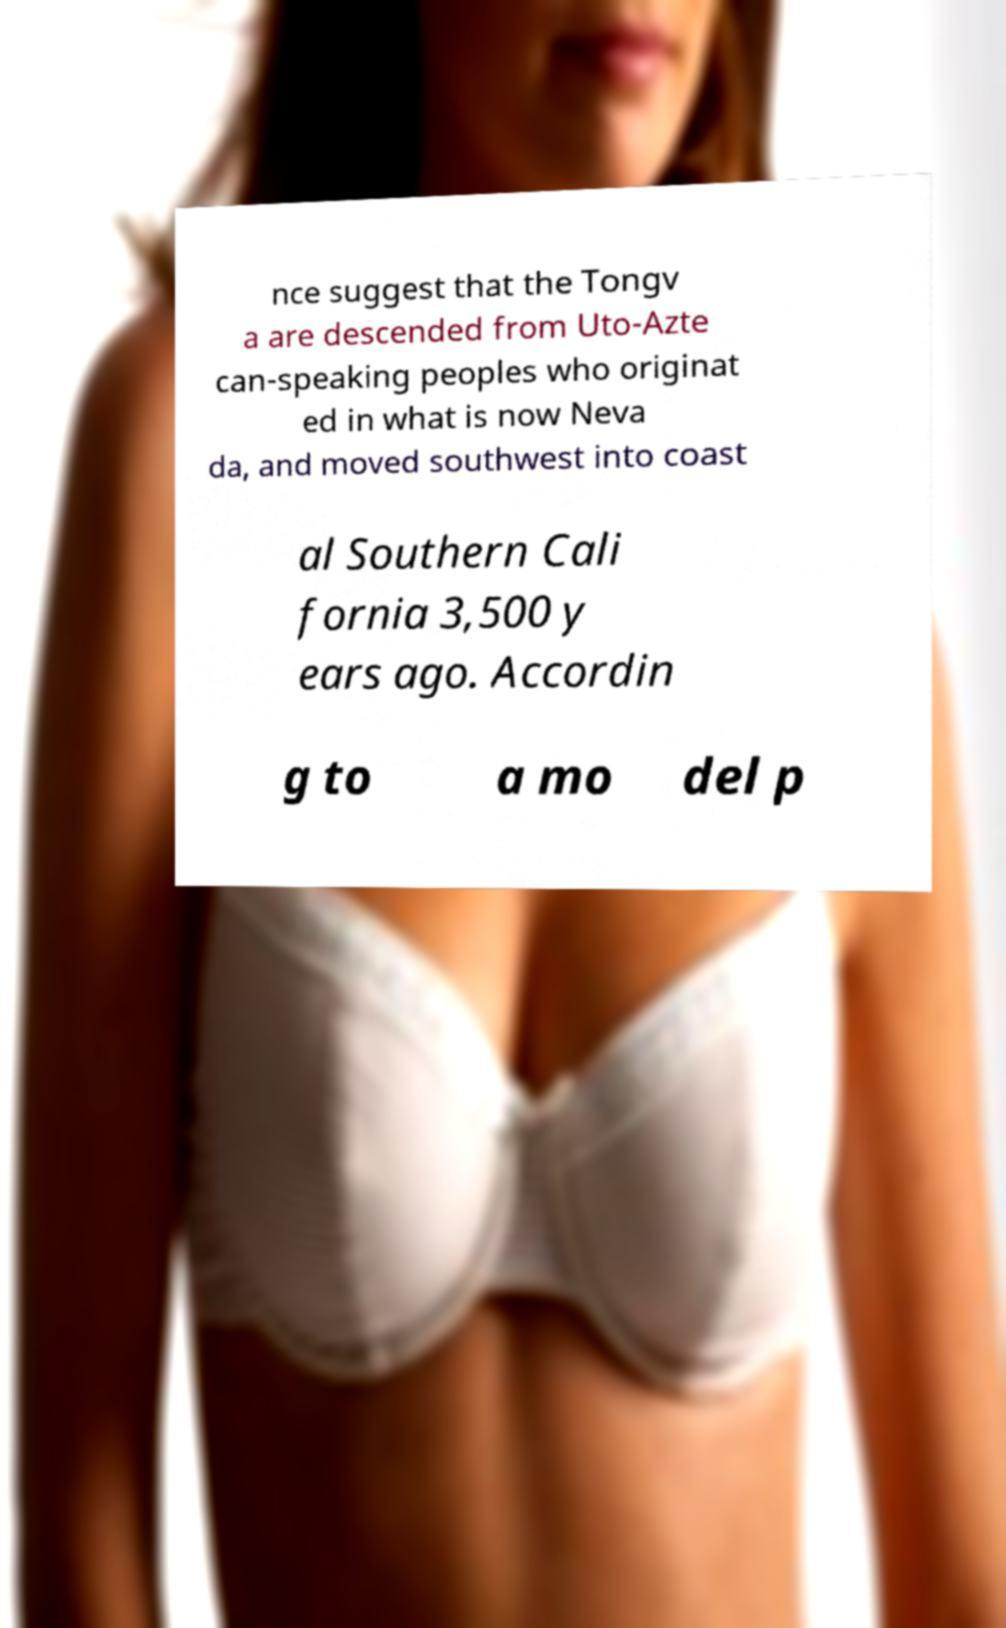Please read and relay the text visible in this image. What does it say? nce suggest that the Tongv a are descended from Uto-Azte can-speaking peoples who originat ed in what is now Neva da, and moved southwest into coast al Southern Cali fornia 3,500 y ears ago. Accordin g to a mo del p 